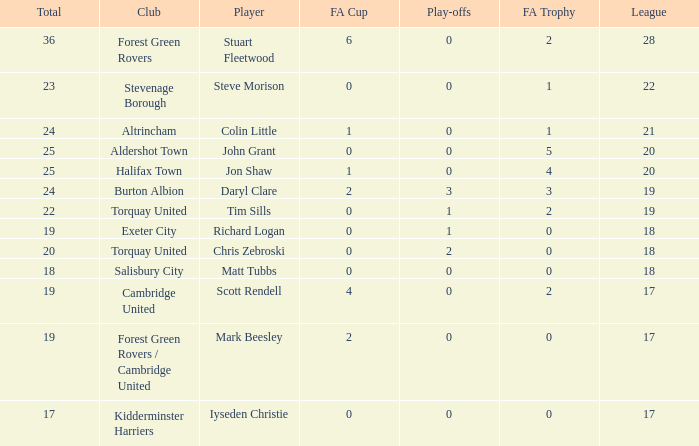What is the mean number of play-offs when the league number was bigger than 18, where the player was John Grant and the total number was bigger than 25? None. 